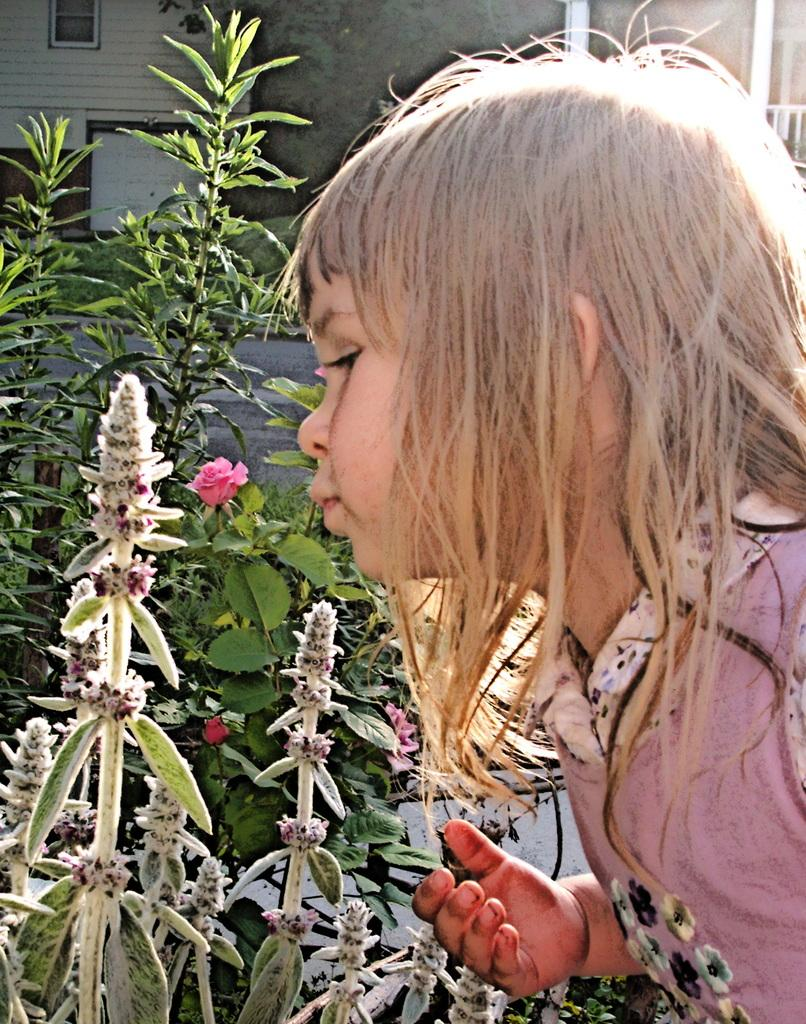Who is the main subject in the picture? There is a girl in the picture. What type of plants can be seen in the image? There are flower plants in the picture. What can be seen in the background of the picture? There is a building and other objects visible in the background of the picture. What type of birthday celebration is the girl attending in the picture? There is no indication of a birthday celebration in the image; it simply features a girl and flower plants. What type of farming equipment can be seen in the picture? There is no farming equipment present in the image. 